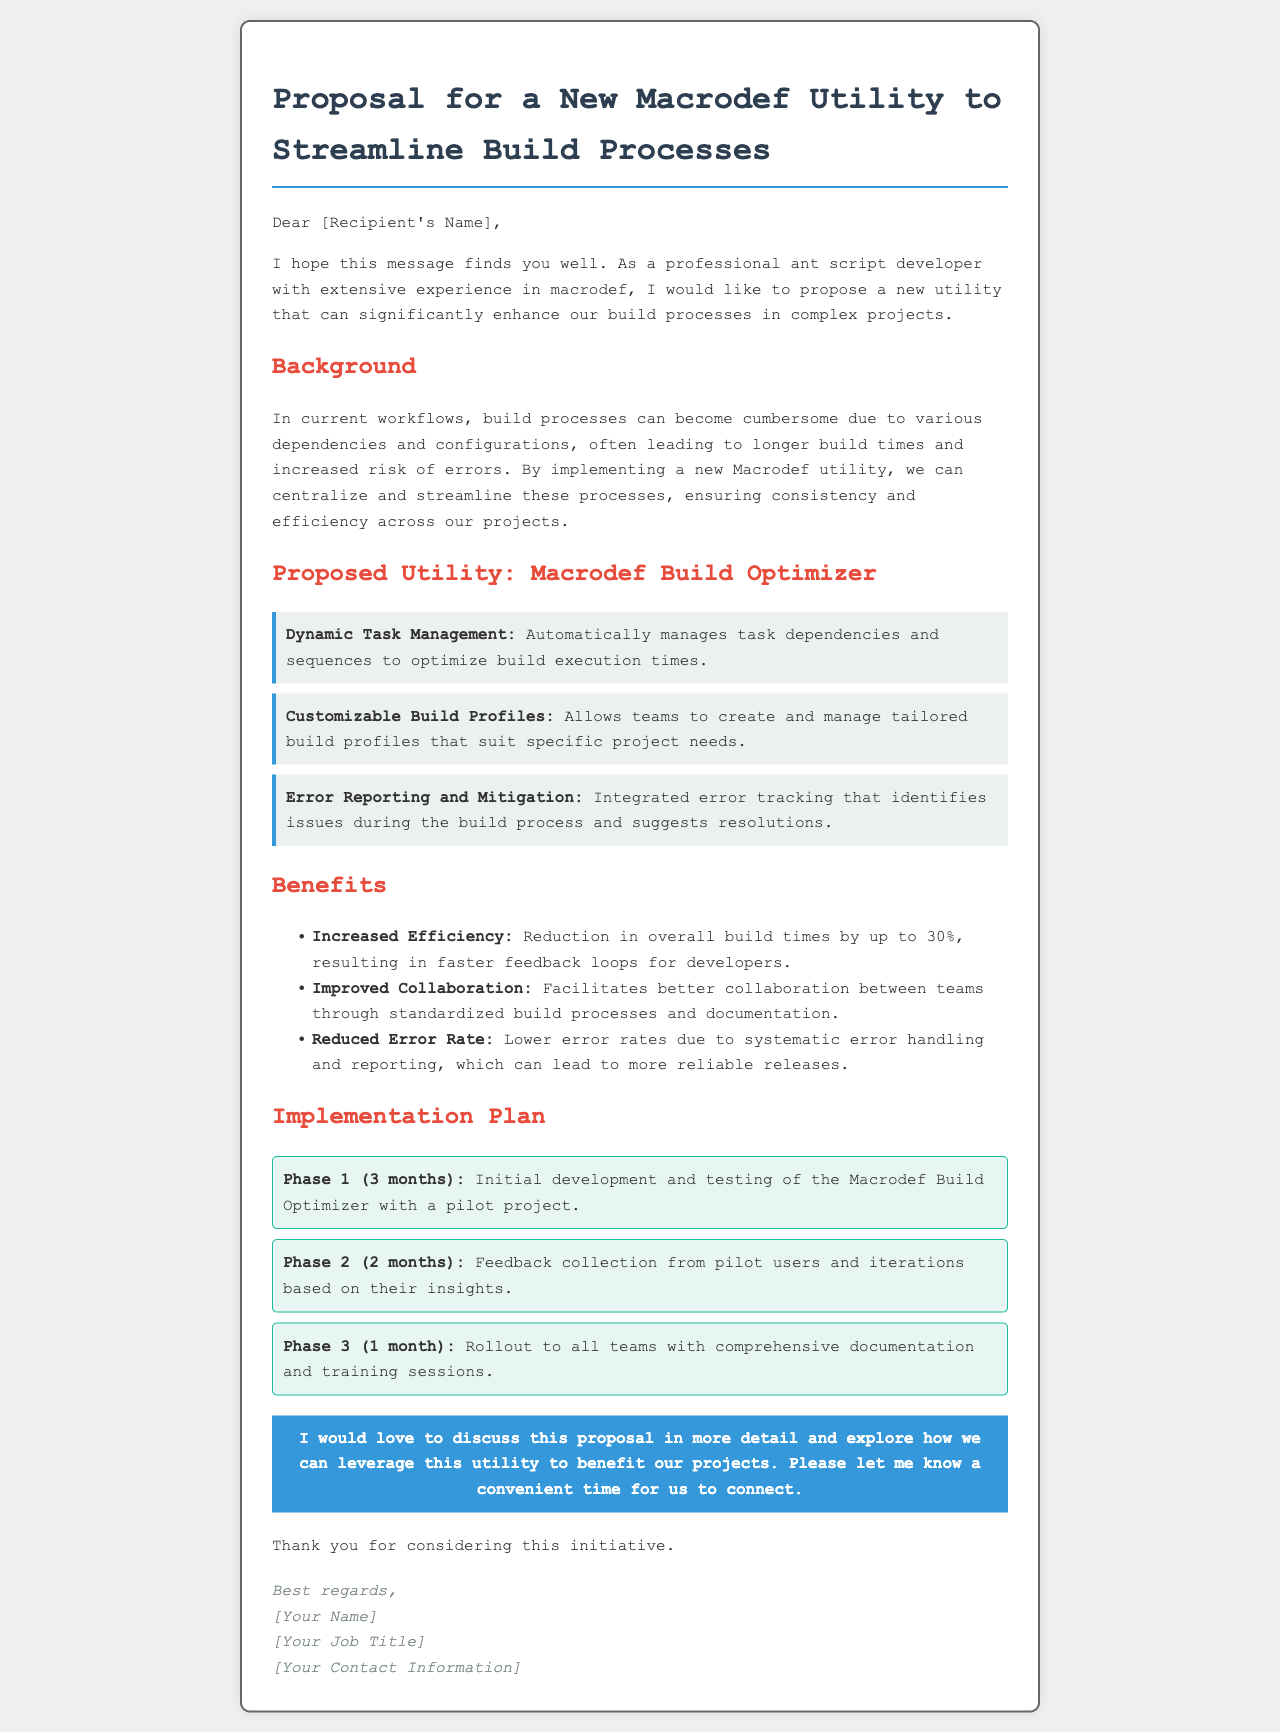What is the title of the proposal? The title is stated in the header of the email, reflecting the subject of the document.
Answer: Proposal for a New Macrodef Utility to Streamline Build Processes Who is the proposal addressed to? The email opens with a generic greeting suggesting it is addressed to a recipient whose name is likely to be filled in.
Answer: [Recipient's Name] What is the first benefit mentioned? The benefits section lists several advantages of the proposed utility, starting with the first one mentioned.
Answer: Increased Efficiency How long is Phase 1 of the implementation plan? The implementation plan outlines the duration of each phase, with Phase 1 specified in months.
Answer: 3 months What percentage reduction in build times is claimed? The proposal provides a specific numerical reduction in build times as part of its benefits.
Answer: up to 30% What feature allows teams to create tailored builds? The features section describes characteristics of the proposed utility, including the one that involves customization.
Answer: Customizable Build Profiles How many total phases are there in the implementation plan? By counting the listed phases in the implementation section, one can determine the total number.
Answer: 3 What is the main goal of the proposed Macrodef utility? The introduction outlines the primary purpose of the proposed utility in relation to build processes.
Answer: Streamline build processes 